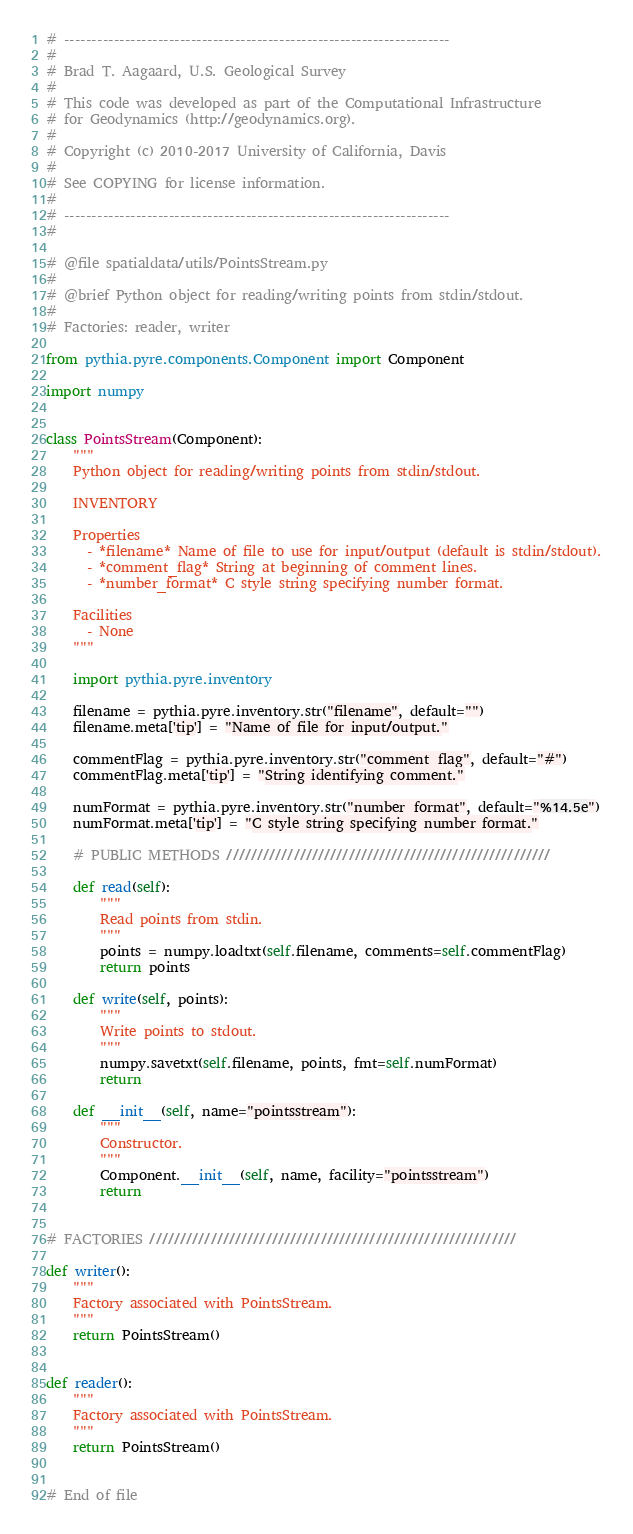<code> <loc_0><loc_0><loc_500><loc_500><_Python_># ----------------------------------------------------------------------
#
# Brad T. Aagaard, U.S. Geological Survey
#
# This code was developed as part of the Computational Infrastructure
# for Geodynamics (http://geodynamics.org).
#
# Copyright (c) 2010-2017 University of California, Davis
#
# See COPYING for license information.
#
# ----------------------------------------------------------------------
#

# @file spatialdata/utils/PointsStream.py
#
# @brief Python object for reading/writing points from stdin/stdout.
#
# Factories: reader, writer

from pythia.pyre.components.Component import Component

import numpy


class PointsStream(Component):
    """
    Python object for reading/writing points from stdin/stdout.

    INVENTORY

    Properties
      - *filename* Name of file to use for input/output (default is stdin/stdout).
      - *comment_flag* String at beginning of comment lines.
      - *number_format* C style string specifying number format.

    Facilities
      - None
    """

    import pythia.pyre.inventory

    filename = pythia.pyre.inventory.str("filename", default="")
    filename.meta['tip'] = "Name of file for input/output."

    commentFlag = pythia.pyre.inventory.str("comment_flag", default="#")
    commentFlag.meta['tip'] = "String identifying comment."

    numFormat = pythia.pyre.inventory.str("number_format", default="%14.5e")
    numFormat.meta['tip'] = "C style string specifying number format."

    # PUBLIC METHODS /////////////////////////////////////////////////////

    def read(self):
        """
        Read points from stdin.
        """
        points = numpy.loadtxt(self.filename, comments=self.commentFlag)
        return points

    def write(self, points):
        """
        Write points to stdout.
        """
        numpy.savetxt(self.filename, points, fmt=self.numFormat)
        return

    def __init__(self, name="pointsstream"):
        """
        Constructor.
        """
        Component.__init__(self, name, facility="pointsstream")
        return


# FACTORIES ////////////////////////////////////////////////////////////

def writer():
    """
    Factory associated with PointsStream.
    """
    return PointsStream()


def reader():
    """
    Factory associated with PointsStream.
    """
    return PointsStream()


# End of file
</code> 